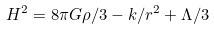Convert formula to latex. <formula><loc_0><loc_0><loc_500><loc_500>H ^ { 2 } = 8 \pi G \rho / 3 - k / r ^ { 2 } + \Lambda / 3</formula> 